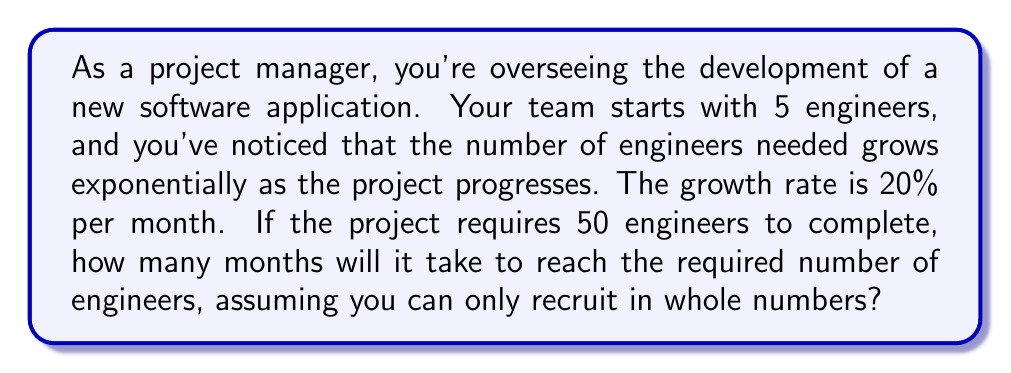Give your solution to this math problem. Let's approach this step-by-step using an exponential growth model:

1) The exponential growth formula is:
   $A = P(1 + r)^t$
   Where:
   $A$ = Final amount
   $P$ = Initial amount
   $r$ = Growth rate (as a decimal)
   $t$ = Time

2) We know:
   $P = 5$ (initial number of engineers)
   $r = 0.20$ (20% growth rate)
   $A = 50$ (target number of engineers)

3) Let's plug these into our formula:
   $50 = 5(1 + 0.20)^t$

4) Simplify:
   $50 = 5(1.20)^t$

5) Divide both sides by 5:
   $10 = (1.20)^t$

6) Take the natural log of both sides:
   $\ln(10) = t \cdot \ln(1.20)$

7) Solve for $t$:
   $t = \frac{\ln(10)}{\ln(1.20)} \approx 12.33$ months

8) Since we can only recruit in whole numbers of engineers, we need to round up to the next whole month. This ensures we have at least 50 engineers.

9) Verify:
   After 13 months: $5(1.20)^{13} \approx 52.94$ engineers
   After 12 months: $5(1.20)^{12} \approx 44.12$ engineers

Therefore, it will take 13 months to reach at least 50 engineers.
Answer: 13 months 